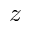<formula> <loc_0><loc_0><loc_500><loc_500>z</formula> 